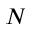Convert formula to latex. <formula><loc_0><loc_0><loc_500><loc_500>N</formula> 